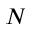Convert formula to latex. <formula><loc_0><loc_0><loc_500><loc_500>N</formula> 